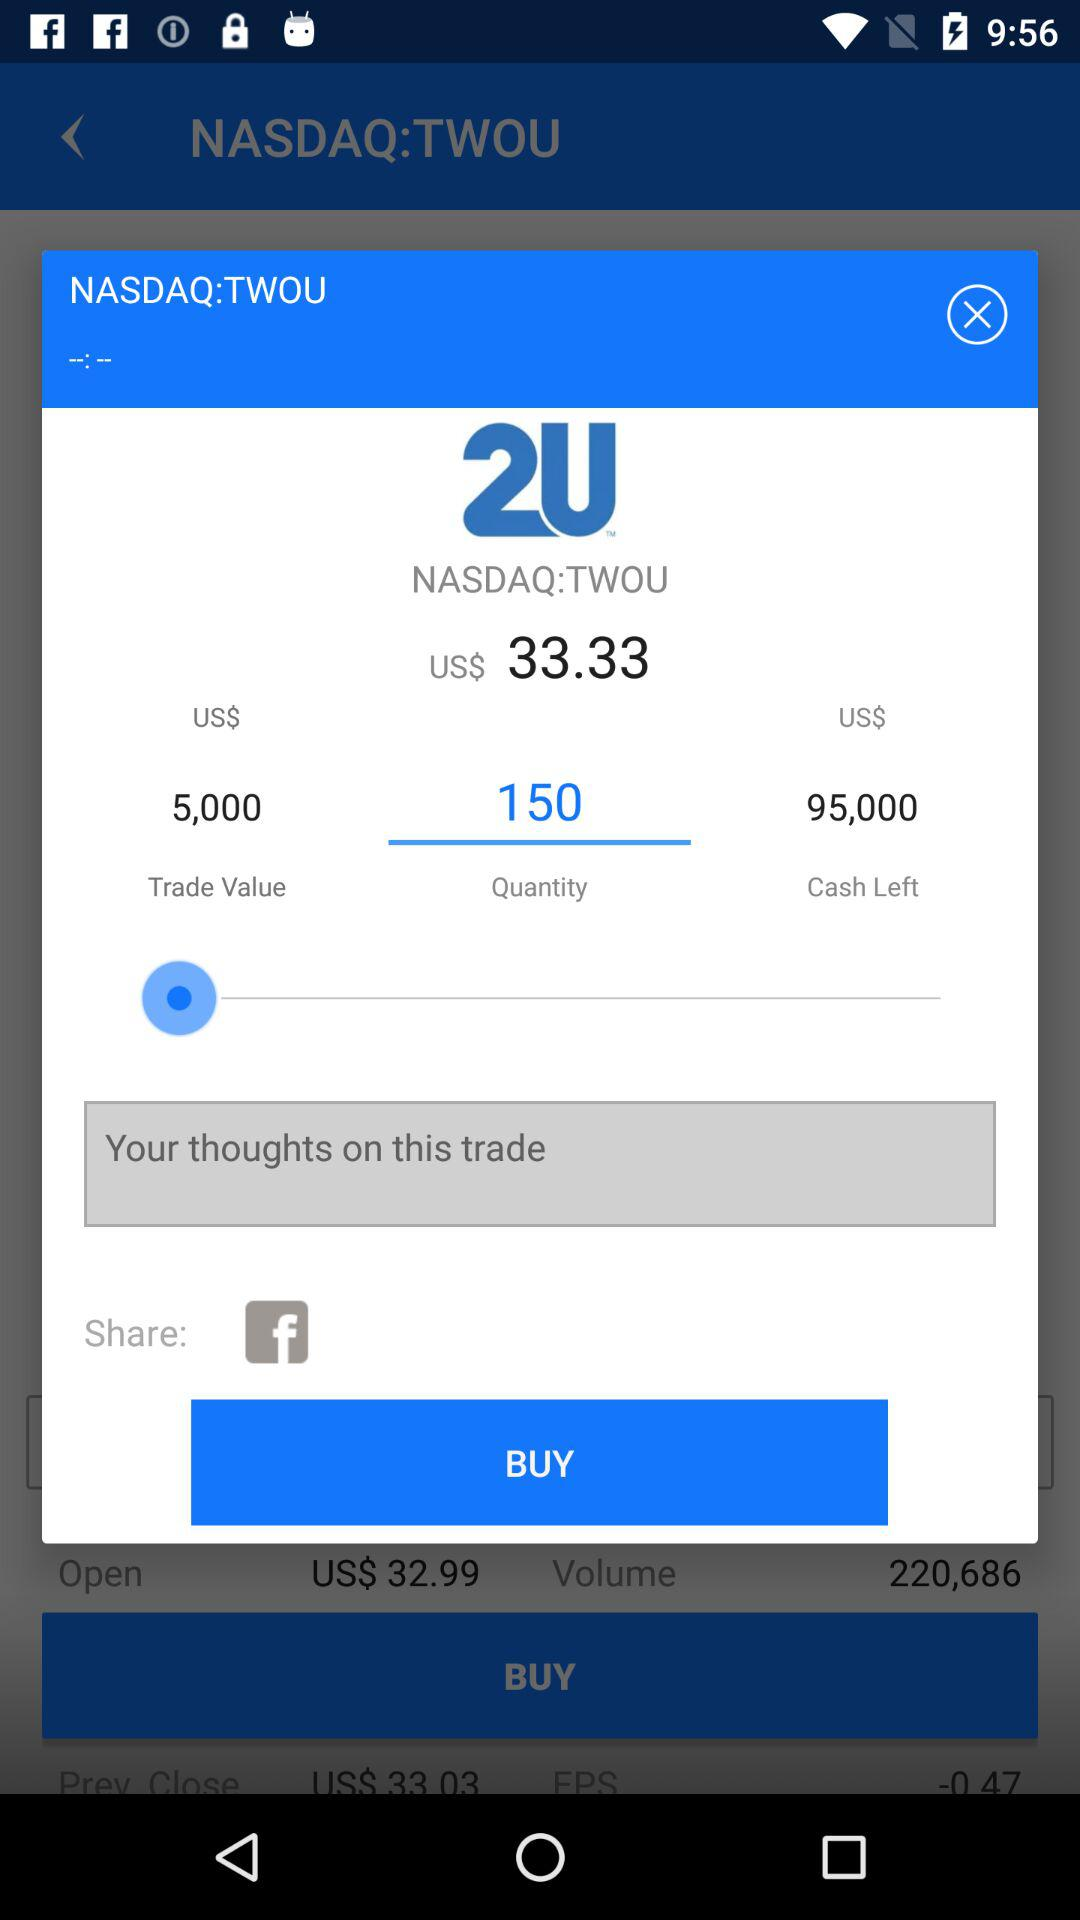What is the name of the application to share? The name of the application to share is "Facebook". 